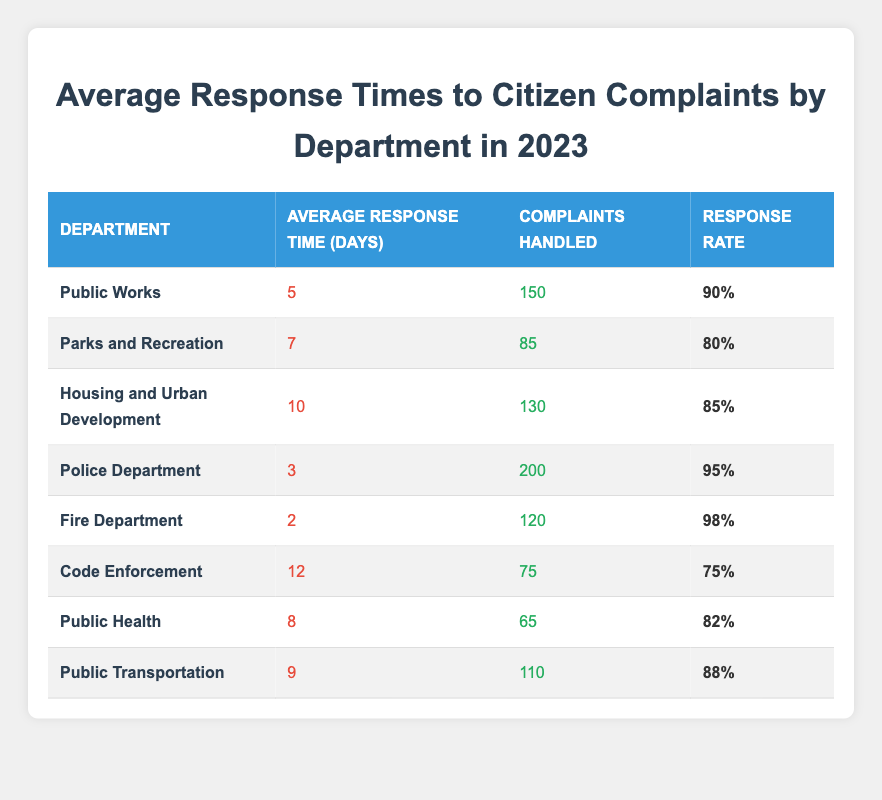What is the average response time for the Police Department? The table indicates that the average response time for the Police Department is listed as 3 days.
Answer: 3 days Which department has the highest response rate? Looking through the response rates in the table, the Fire Department has a response rate of 98%, which is the highest among all departments.
Answer: Fire Department How many complaints were handled by the Public Works department? The number of complaints handled by the Public Works department is directly given in the table as 150.
Answer: 150 What is the total number of complaints handled by the Housing and Urban Development and Code Enforcement departments combined? To calculate the total, we take the complaints handled by Housing and Urban Development (130) and add it to Code Enforcement (75): 130 + 75 = 205.
Answer: 205 Is the response rate for the Parks and Recreation department higher than 85%? The response rate for Parks and Recreation is noted as 80%, which is lower than 85%. Therefore, the statement is false.
Answer: No Which department has the longest average response time, and what is it? By comparing the average response times, Code Enforcement has the longest response time at 12 days.
Answer: Code Enforcement, 12 days What is the average response time across all departments? To find the average, we first sum the average response times (5 + 7 + 10 + 3 + 2 + 12 + 8 + 9 = 66) and divide by the number of departments (8): 66 / 8 = 8.25 days.
Answer: 8.25 days Does the Fire Department handle more complaints than the Public Health department? The Fire Department handled 120 complaints, and the Public Health department handled 65 complaints. Since 120 is greater than 65, the statement is true.
Answer: Yes Which department's average response time is closest to the overall average calculated earlier? The overall average response time is 8.25 days; the Parks and Recreation department has an average response time of 7 days, which is the closest.
Answer: Parks and Recreation 